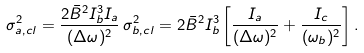Convert formula to latex. <formula><loc_0><loc_0><loc_500><loc_500>\sigma ^ { 2 } _ { a , c l } = \frac { 2 \bar { B } ^ { 2 } I _ { b } ^ { 3 } I _ { a } } { ( \Delta \omega ) ^ { 2 } } \, \sigma ^ { 2 } _ { b , c l } = 2 \bar { B } ^ { 2 } I _ { b } ^ { 3 } \left [ \frac { I _ { a } } { ( \Delta \omega ) ^ { 2 } } + \frac { I _ { c } } { ( \omega _ { b } ) ^ { 2 } } \right ] .</formula> 